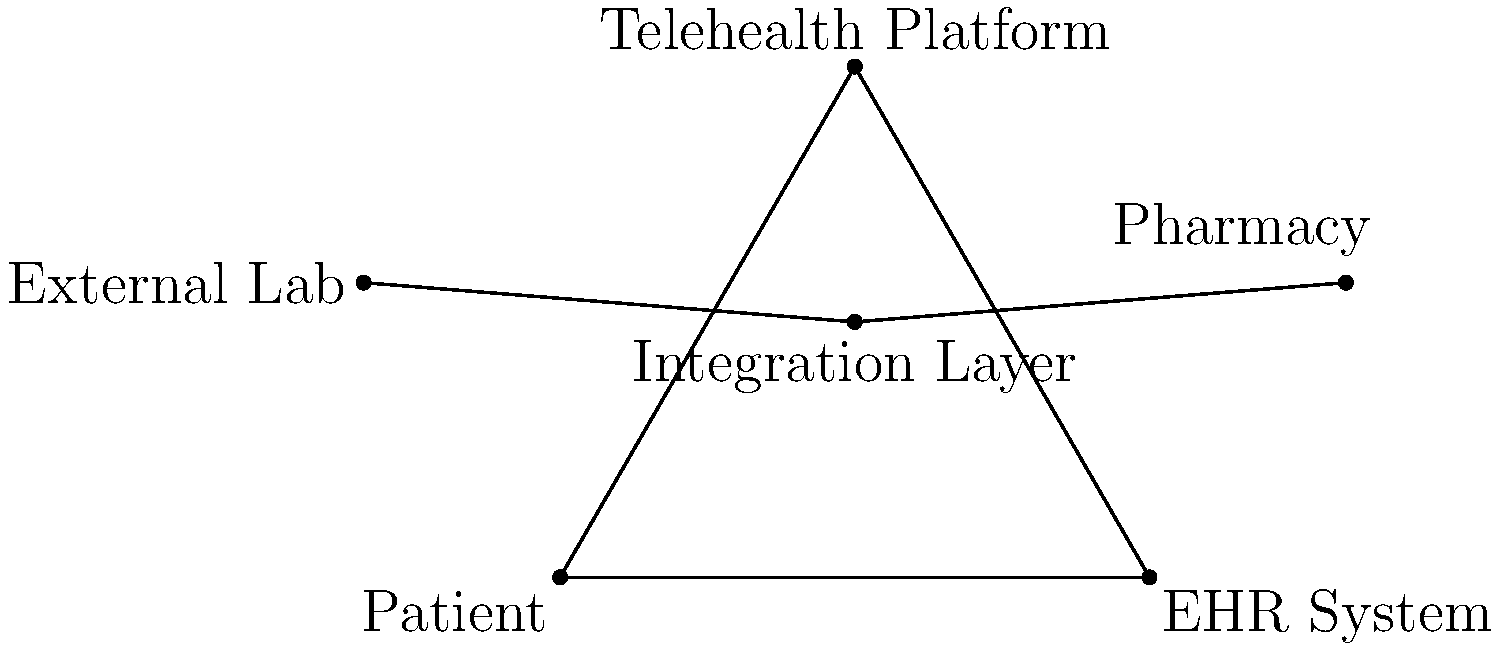In the given entity-relationship diagram representing patient data integration across different healthcare systems, which component serves as the central hub for data exchange and acts as a bridge between the Patient, EHR System, and Telehealth Platform entities? To answer this question, let's analyze the entity-relationship diagram step by step:

1. Identify the main entities in the diagram:
   - Patient
   - EHR (Electronic Health Record) System
   - Telehealth Platform
   - Integration Layer
   - External Lab
   - Pharmacy

2. Observe the relationships between these entities:
   - The Patient, EHR System, and Telehealth Platform form a triangle, indicating they are closely related.
   - The Integration Layer is positioned at the center of this triangle.

3. Analyze the role of the Integration Layer:
   - It has direct connections to the Patient, EHR System, and Telehealth Platform.
   - It also connects to external entities like the External Lab and Pharmacy.

4. Consider the function of an integration layer in healthcare IT:
   - It typically serves as a middleware that facilitates data exchange between different systems.
   - It ensures interoperability and seamless communication between various healthcare applications and databases.

5. Evaluate the question asked:
   - We're looking for a component that acts as a central hub for data exchange.
   - We need to identify which entity bridges the Patient, EHR System, and Telehealth Platform.

6. Conclusion:
   Based on its position in the diagram and its typical role in healthcare IT architectures, the Integration Layer is the component that serves as the central hub for data exchange and acts as a bridge between the Patient, EHR System, and Telehealth Platform entities.
Answer: Integration Layer 